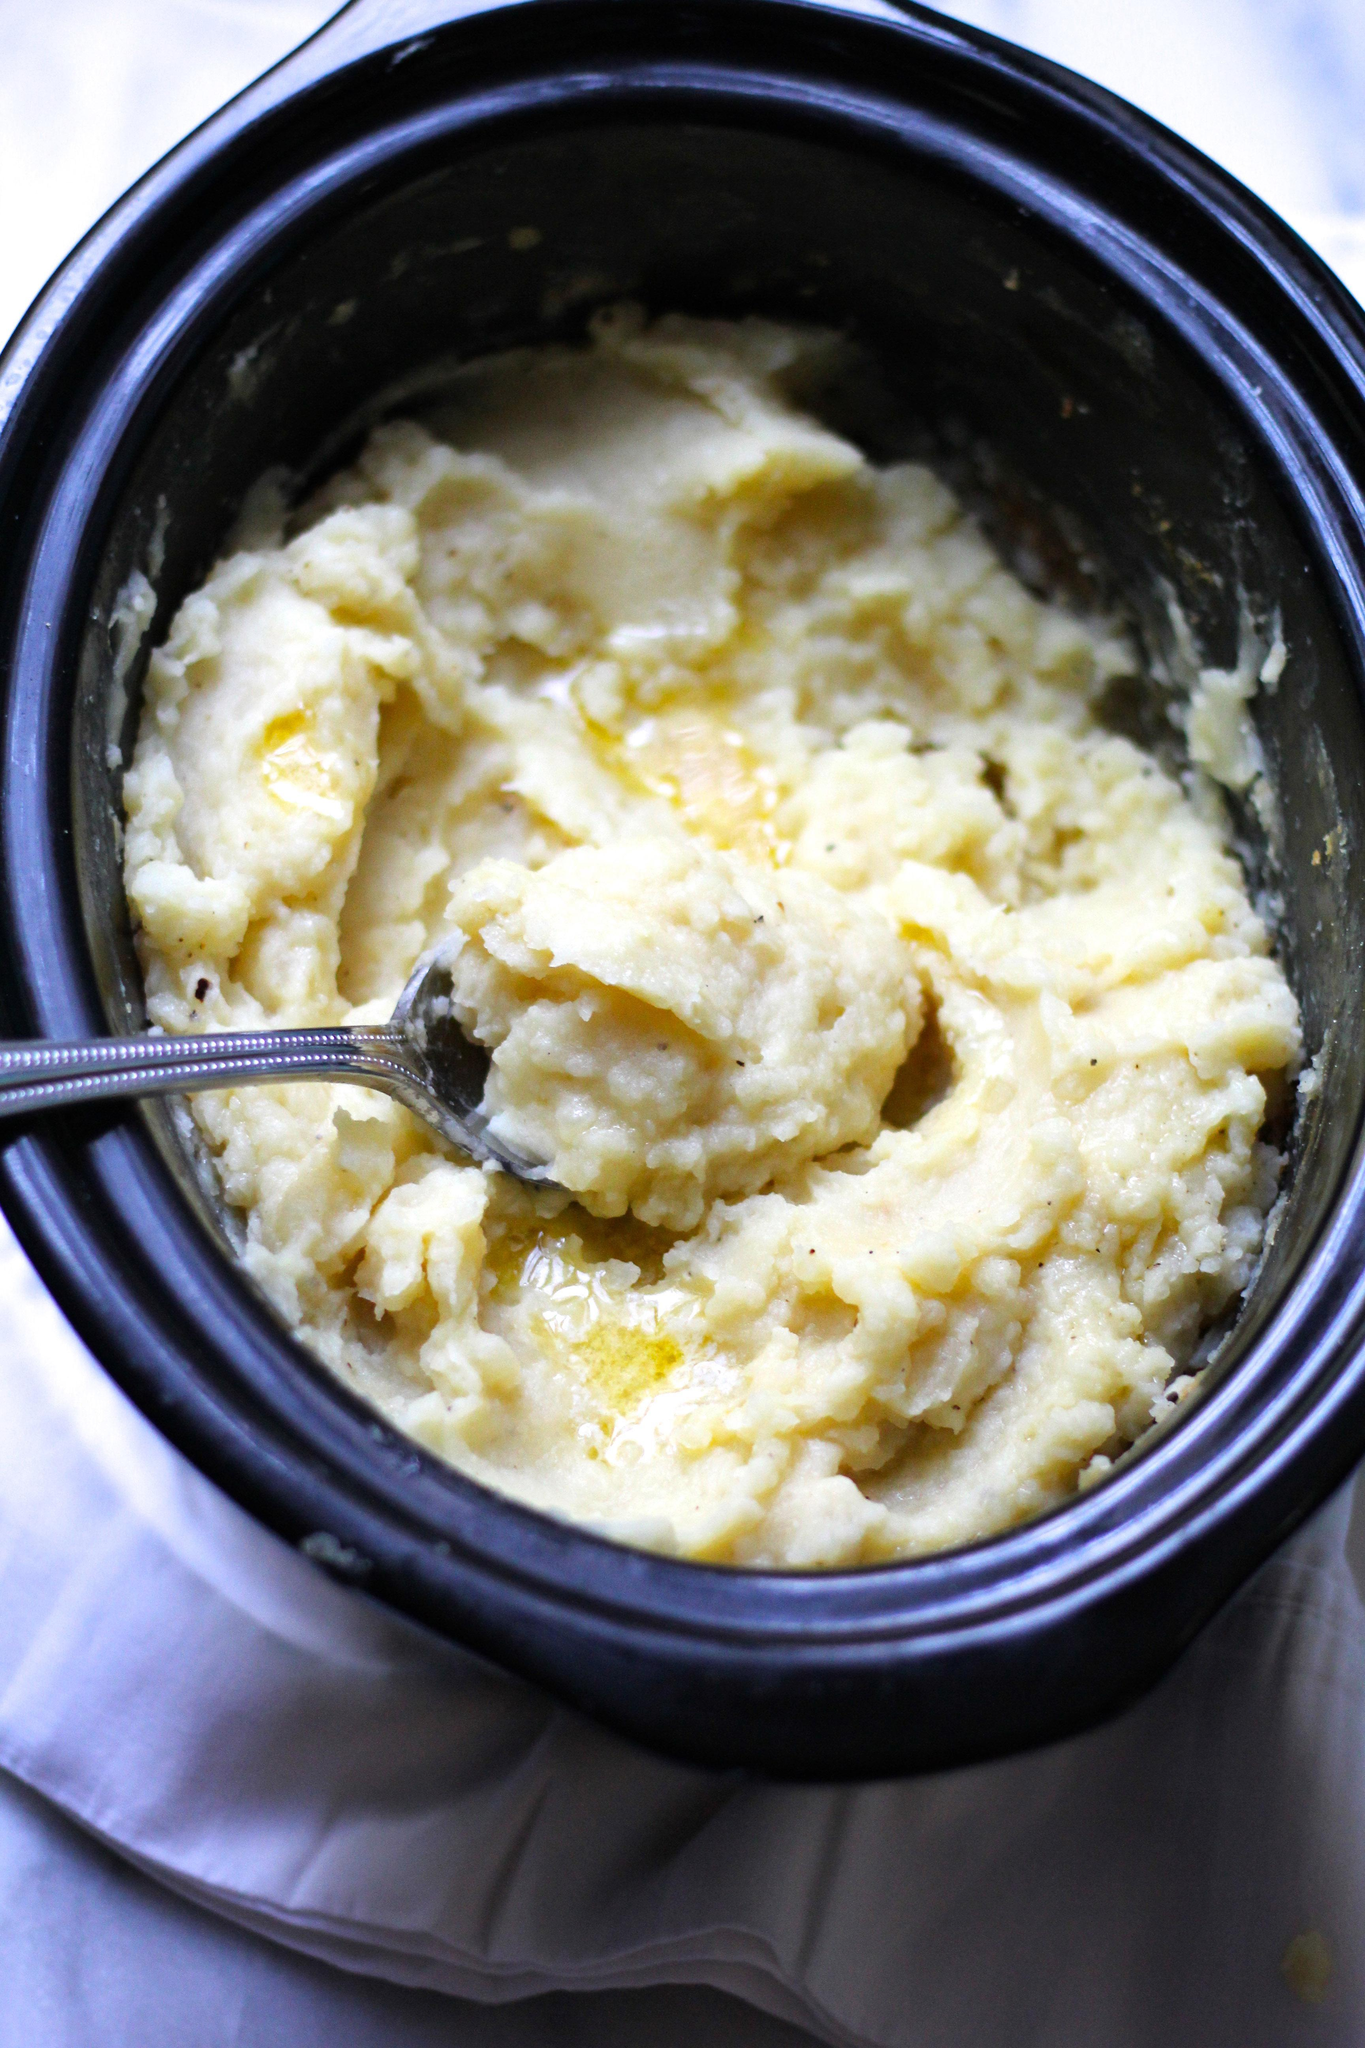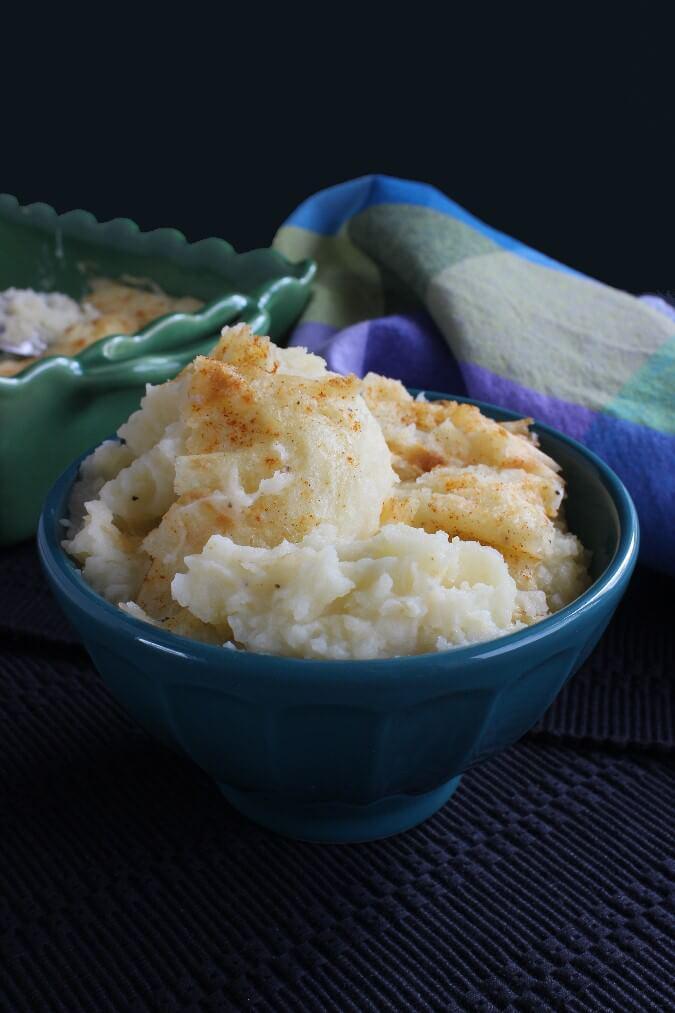The first image is the image on the left, the second image is the image on the right. Evaluate the accuracy of this statement regarding the images: "A spoon is in a bowl of mashed potatoes in one image.". Is it true? Answer yes or no. Yes. The first image is the image on the left, the second image is the image on the right. Given the left and right images, does the statement "In one image, there is a spoon in the mashed potatoes that is resting on the side of the container that the potatoes are in." hold true? Answer yes or no. Yes. 